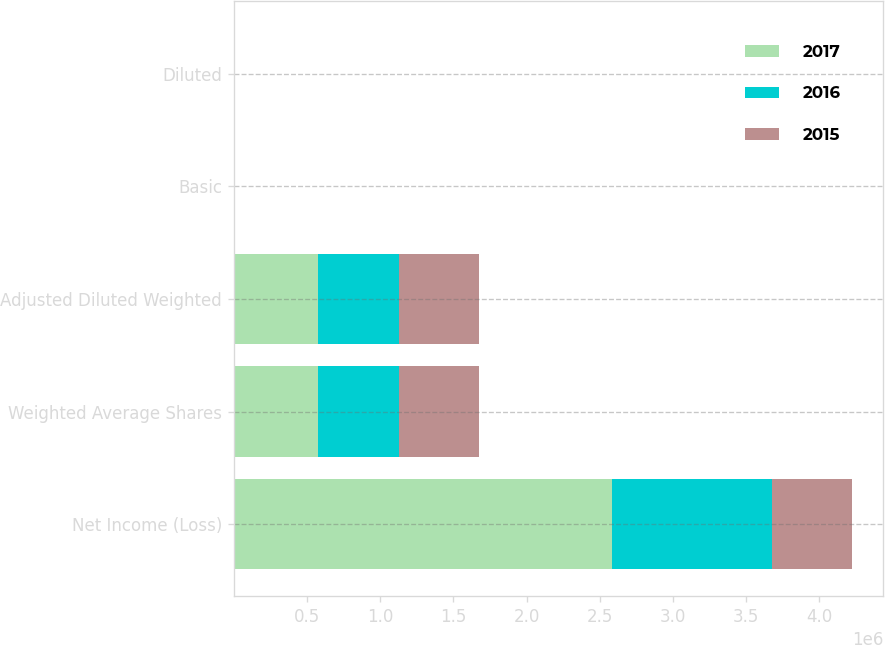Convert chart. <chart><loc_0><loc_0><loc_500><loc_500><stacked_bar_chart><ecel><fcel>Net Income (Loss)<fcel>Weighted Average Shares<fcel>Adjusted Diluted Weighted<fcel>Basic<fcel>Diluted<nl><fcel>2017<fcel>2.58258e+06<fcel>574620<fcel>578693<fcel>4.49<fcel>4.46<nl><fcel>2016<fcel>1.09669e+06<fcel>553384<fcel>553384<fcel>1.98<fcel>1.98<nl><fcel>2015<fcel>545697<fcel>545697<fcel>545697<fcel>8.29<fcel>8.29<nl></chart> 